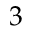<formula> <loc_0><loc_0><loc_500><loc_500>3</formula> 